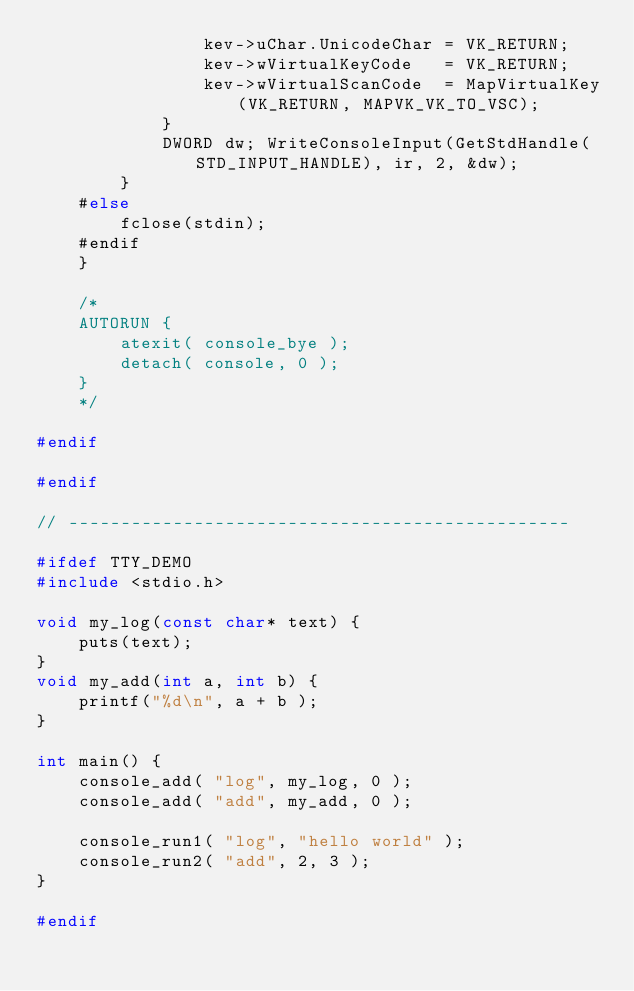<code> <loc_0><loc_0><loc_500><loc_500><_C_>                kev->uChar.UnicodeChar = VK_RETURN;
                kev->wVirtualKeyCode   = VK_RETURN;
                kev->wVirtualScanCode  = MapVirtualKey(VK_RETURN, MAPVK_VK_TO_VSC);
            }
            DWORD dw; WriteConsoleInput(GetStdHandle(STD_INPUT_HANDLE), ir, 2, &dw);
        }
    #else
        fclose(stdin);
    #endif
    }

    /*
    AUTORUN {
        atexit( console_bye );
        detach( console, 0 );
    }
    */

#endif

#endif

// ------------------------------------------------

#ifdef TTY_DEMO
#include <stdio.h>

void my_log(const char* text) {
    puts(text);
}
void my_add(int a, int b) {
    printf("%d\n", a + b );
}

int main() {
    console_add( "log", my_log, 0 );
    console_add( "add", my_add, 0 );

    console_run1( "log", "hello world" );
    console_run2( "add", 2, 3 );
}

#endif
</code> 